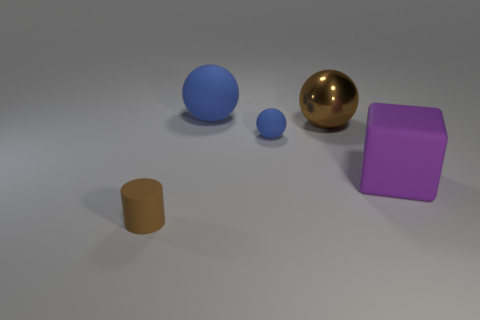Is there any other thing that is made of the same material as the brown ball?
Provide a succinct answer. No. Is the large block made of the same material as the small brown cylinder?
Offer a very short reply. Yes. Is the number of small blue balls that are behind the small blue sphere the same as the number of large objects that are on the left side of the brown rubber thing?
Provide a short and direct response. Yes. Are there any tiny brown matte things that are on the left side of the object that is in front of the large object that is in front of the big metallic object?
Ensure brevity in your answer.  No. Is the size of the brown rubber thing the same as the purple rubber thing?
Offer a terse response. No. There is a large ball on the right side of the large object to the left of the blue thing that is in front of the large blue rubber sphere; what color is it?
Make the answer very short. Brown. How many matte things have the same color as the large cube?
Offer a terse response. 0. What number of big objects are green cylinders or blue objects?
Give a very brief answer. 1. Are there any other small blue things that have the same shape as the tiny blue object?
Offer a very short reply. No. Do the large purple rubber object and the small blue thing have the same shape?
Keep it short and to the point. No. 